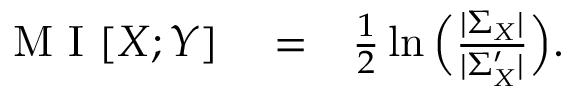Convert formula to latex. <formula><loc_0><loc_0><loc_500><loc_500>\begin{array} { r l r } { M I [ X ; Y ] } & = } & { \frac { 1 } { 2 } \ln \left ( \frac { | \Sigma _ { X } | } { | \Sigma _ { X } ^ { \prime } | } \right ) . } \end{array}</formula> 